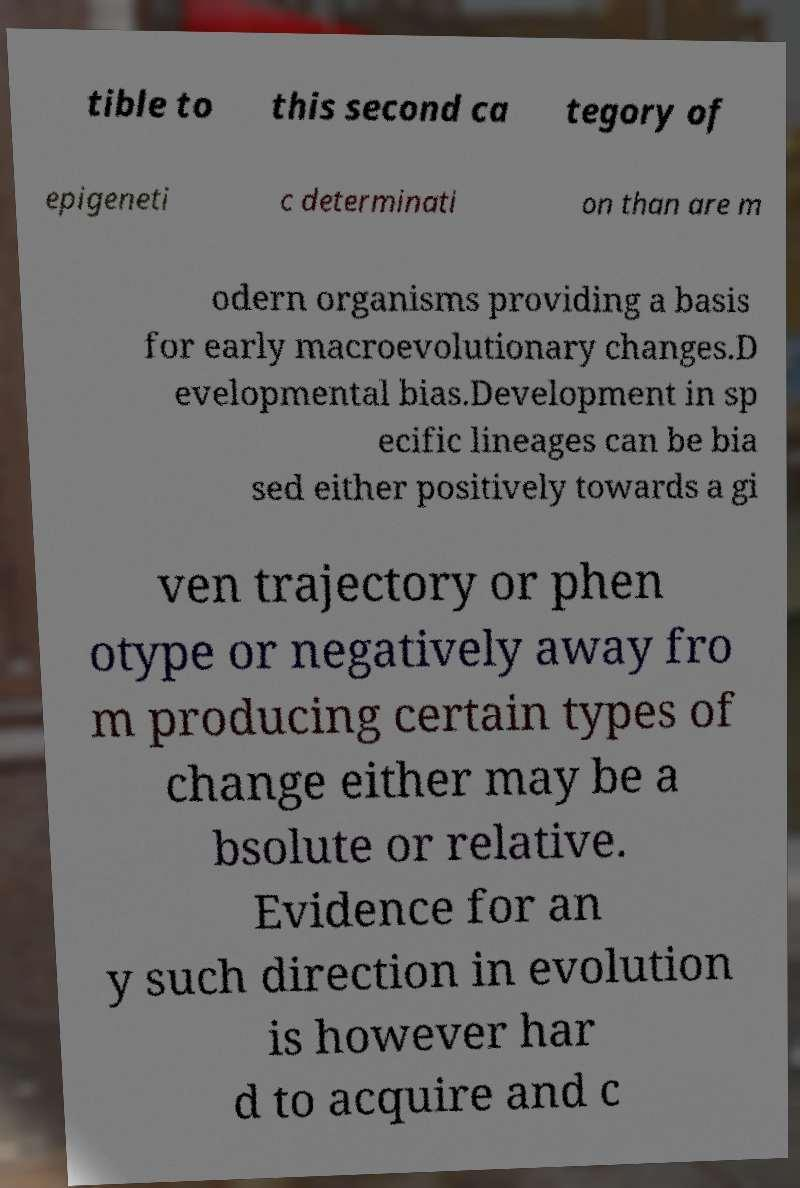Please identify and transcribe the text found in this image. tible to this second ca tegory of epigeneti c determinati on than are m odern organisms providing a basis for early macroevolutionary changes.D evelopmental bias.Development in sp ecific lineages can be bia sed either positively towards a gi ven trajectory or phen otype or negatively away fro m producing certain types of change either may be a bsolute or relative. Evidence for an y such direction in evolution is however har d to acquire and c 